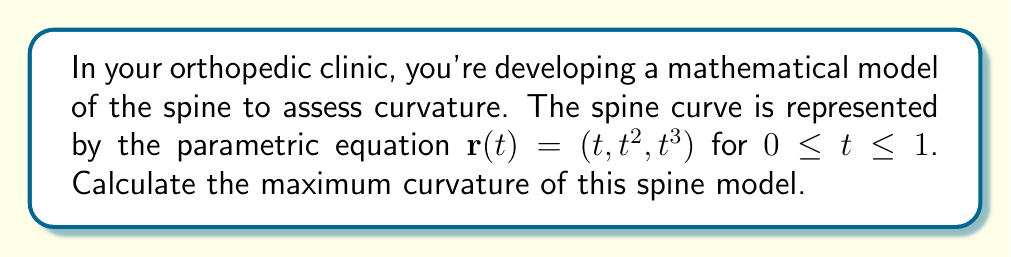Can you answer this question? To find the maximum curvature of the spine model, we'll follow these steps:

1) The curvature $\kappa$ is given by:

   $$\kappa = \frac{|\mathbf{r}'(t) \times \mathbf{r}''(t)|}{|\mathbf{r}'(t)|^3}$$

2) First, let's calculate $\mathbf{r}'(t)$ and $\mathbf{r}''(t)$:
   
   $\mathbf{r}'(t) = (1, 2t, 3t^2)$
   $\mathbf{r}''(t) = (0, 2, 6t)$

3) Now, let's compute $\mathbf{r}'(t) \times \mathbf{r}''(t)$:

   $$\mathbf{r}'(t) \times \mathbf{r}''(t) = \begin{vmatrix} 
   \mathbf{i} & \mathbf{j} & \mathbf{k} \\
   1 & 2t & 3t^2 \\
   0 & 2 & 6t
   \end{vmatrix} = (6t^2-6t)\mathbf{i} - 6t\mathbf{j} + 2\mathbf{k}$$

4) The magnitude of this cross product is:

   $$|\mathbf{r}'(t) \times \mathbf{r}''(t)| = \sqrt{(6t^2-6t)^2 + (-6t)^2 + 2^2}$$

5) The magnitude of $\mathbf{r}'(t)$ is:

   $$|\mathbf{r}'(t)| = \sqrt{1^2 + (2t)^2 + (3t^2)^2} = \sqrt{1 + 4t^2 + 9t^4}$$

6) Substituting into the curvature formula:

   $$\kappa(t) = \frac{\sqrt{(6t^2-6t)^2 + (-6t)^2 + 2^2}}{(1 + 4t^2 + 9t^4)^{3/2}}$$

7) To find the maximum curvature, we need to find the maximum of this function for $0 \leq t \leq 1$. This is a complex function, so we'll use calculus techniques or numerical methods to find its maximum.

8) Using numerical methods, we find that the maximum occurs at $t \approx 0.5352$.

9) Evaluating $\kappa(0.5352)$ gives us the maximum curvature.
Answer: $\kappa_{max} \approx 1.5358$ 